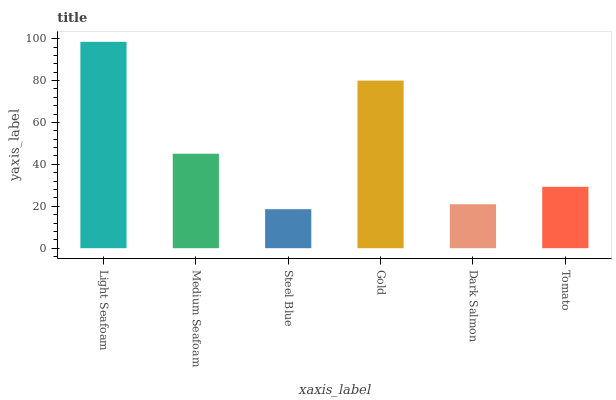Is Steel Blue the minimum?
Answer yes or no. Yes. Is Light Seafoam the maximum?
Answer yes or no. Yes. Is Medium Seafoam the minimum?
Answer yes or no. No. Is Medium Seafoam the maximum?
Answer yes or no. No. Is Light Seafoam greater than Medium Seafoam?
Answer yes or no. Yes. Is Medium Seafoam less than Light Seafoam?
Answer yes or no. Yes. Is Medium Seafoam greater than Light Seafoam?
Answer yes or no. No. Is Light Seafoam less than Medium Seafoam?
Answer yes or no. No. Is Medium Seafoam the high median?
Answer yes or no. Yes. Is Tomato the low median?
Answer yes or no. Yes. Is Tomato the high median?
Answer yes or no. No. Is Steel Blue the low median?
Answer yes or no. No. 